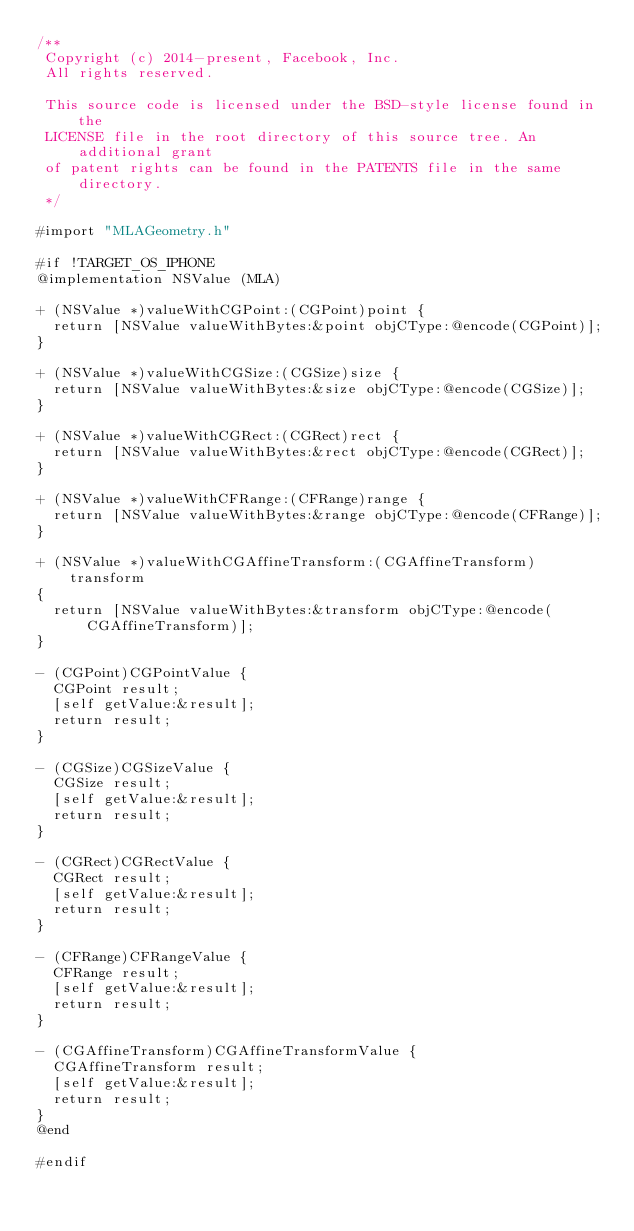<code> <loc_0><loc_0><loc_500><loc_500><_ObjectiveC_>/**
 Copyright (c) 2014-present, Facebook, Inc.
 All rights reserved.
 
 This source code is licensed under the BSD-style license found in the
 LICENSE file in the root directory of this source tree. An additional grant
 of patent rights can be found in the PATENTS file in the same directory.
 */

#import "MLAGeometry.h"

#if !TARGET_OS_IPHONE
@implementation NSValue (MLA)

+ (NSValue *)valueWithCGPoint:(CGPoint)point {
  return [NSValue valueWithBytes:&point objCType:@encode(CGPoint)];
}

+ (NSValue *)valueWithCGSize:(CGSize)size {
  return [NSValue valueWithBytes:&size objCType:@encode(CGSize)];
}

+ (NSValue *)valueWithCGRect:(CGRect)rect {
  return [NSValue valueWithBytes:&rect objCType:@encode(CGRect)];
}

+ (NSValue *)valueWithCFRange:(CFRange)range {
  return [NSValue valueWithBytes:&range objCType:@encode(CFRange)];
}

+ (NSValue *)valueWithCGAffineTransform:(CGAffineTransform)transform
{
  return [NSValue valueWithBytes:&transform objCType:@encode(CGAffineTransform)];
}

- (CGPoint)CGPointValue {
  CGPoint result;
  [self getValue:&result];
  return result;
}

- (CGSize)CGSizeValue {
  CGSize result;
  [self getValue:&result];
  return result;
}

- (CGRect)CGRectValue {
  CGRect result;
  [self getValue:&result];
  return result;
}

- (CFRange)CFRangeValue {
  CFRange result;
  [self getValue:&result];
  return result;
}

- (CGAffineTransform)CGAffineTransformValue {
  CGAffineTransform result;
  [self getValue:&result];
  return result;
}
@end

#endif
</code> 